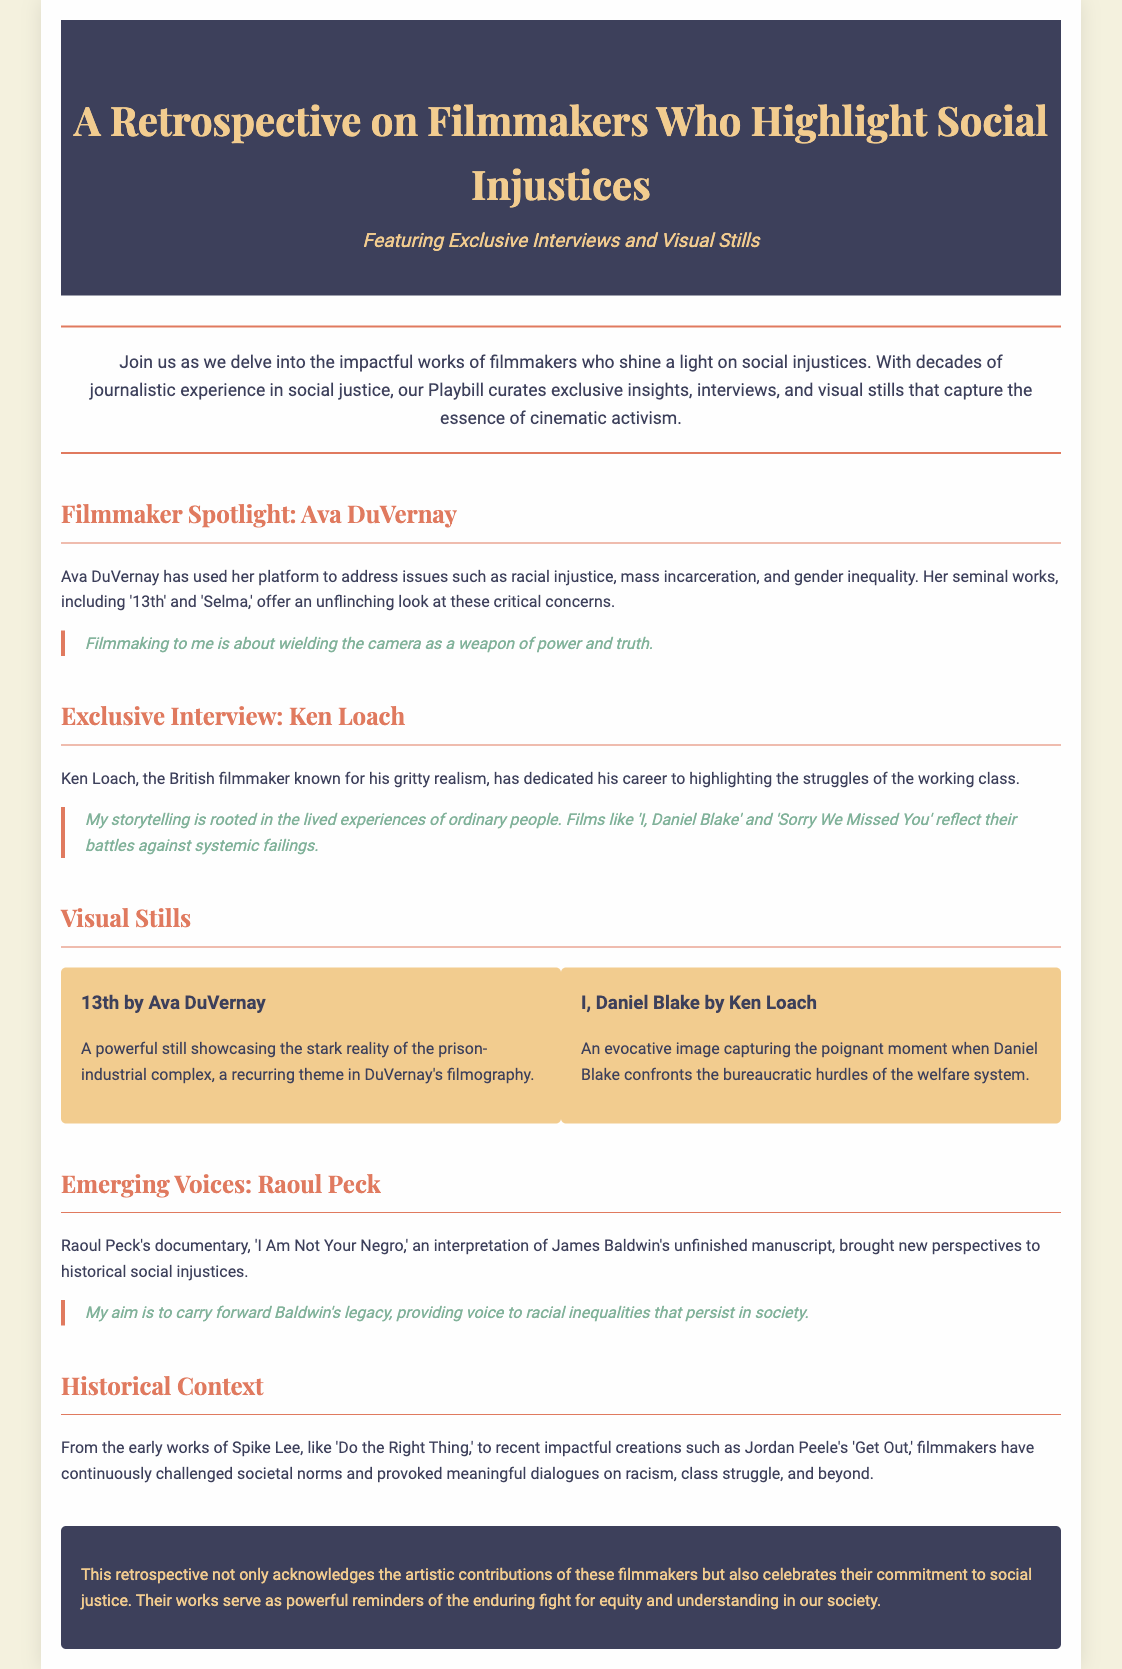What is the title of the retrospective? The title of the retrospective is mentioned at the top of the document.
Answer: A Retrospective on Filmmakers Who Highlight Social Injustices Who is the first filmmaker spotlighted? The first filmmaker spotlighted in the document is mentioned in a designated section.
Answer: Ava DuVernay What film does Ava DuVernay's still represent? The film represented by Ava DuVernay's still is detailed in the visuals section.
Answer: 13th Which filmmaker's work is described as reflecting the struggles of the working class? The document specifies a filmmaker known for this dedication in the exclusive interview section.
Answer: Ken Loach What is the name of Raoul Peck's documentary? The documentary by Raoul Peck is provided in the emerging voices section.
Answer: I Am Not Your Negro What theme is highlighted in DuVernay's filmography? This theme is discussed in relation to her works in the document.
Answer: The prison-industrial complex How are filmmakers described in the historical context section? The historical context section discusses filmmakers' contributions and societal challenges.
Answer: They challenge societal norms What type of reflections are showcased in this retrospective? The document indicates the overall purpose and focus of the retrospective.
Answer: Artistic contributions and commitment to social justice 